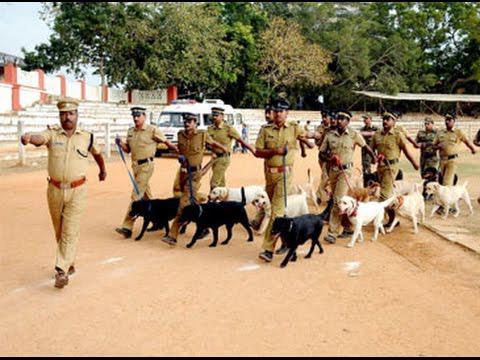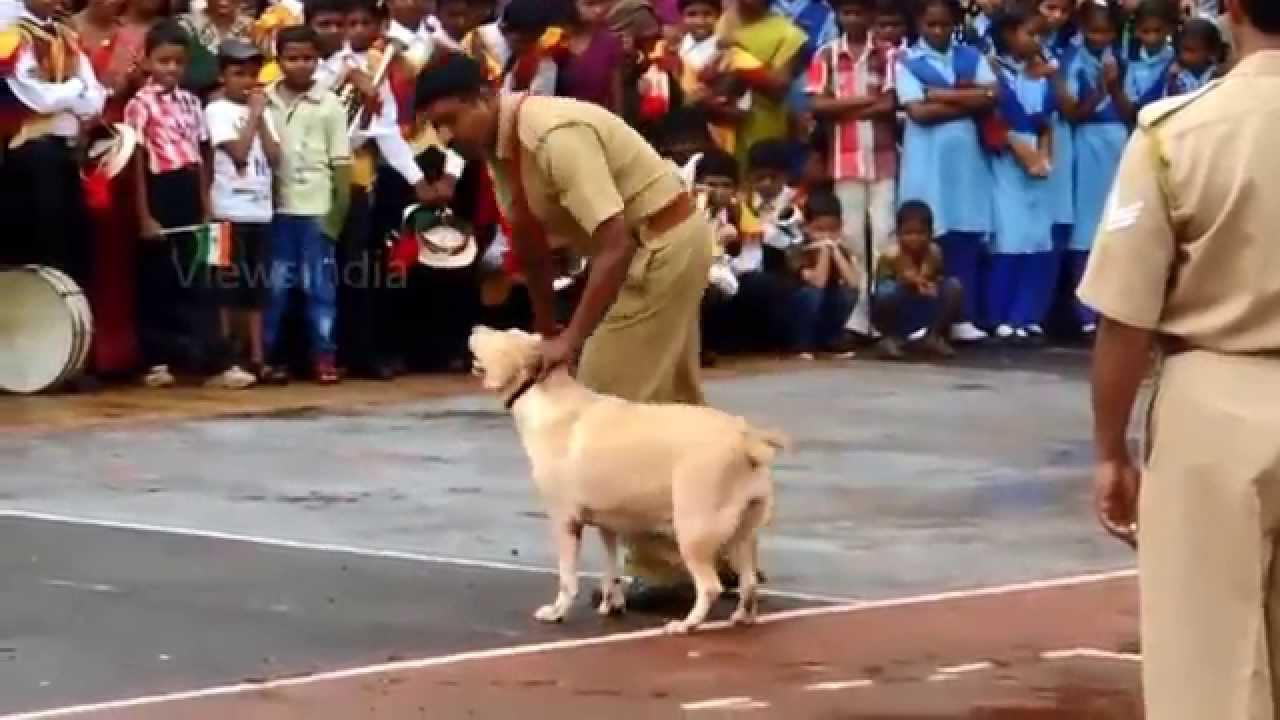The first image is the image on the left, the second image is the image on the right. Evaluate the accuracy of this statement regarding the images: "In one of the images, only one dog is present.". Is it true? Answer yes or no. Yes. The first image is the image on the left, the second image is the image on the right. Analyze the images presented: Is the assertion "At least one dog is sitting." valid? Answer yes or no. No. 